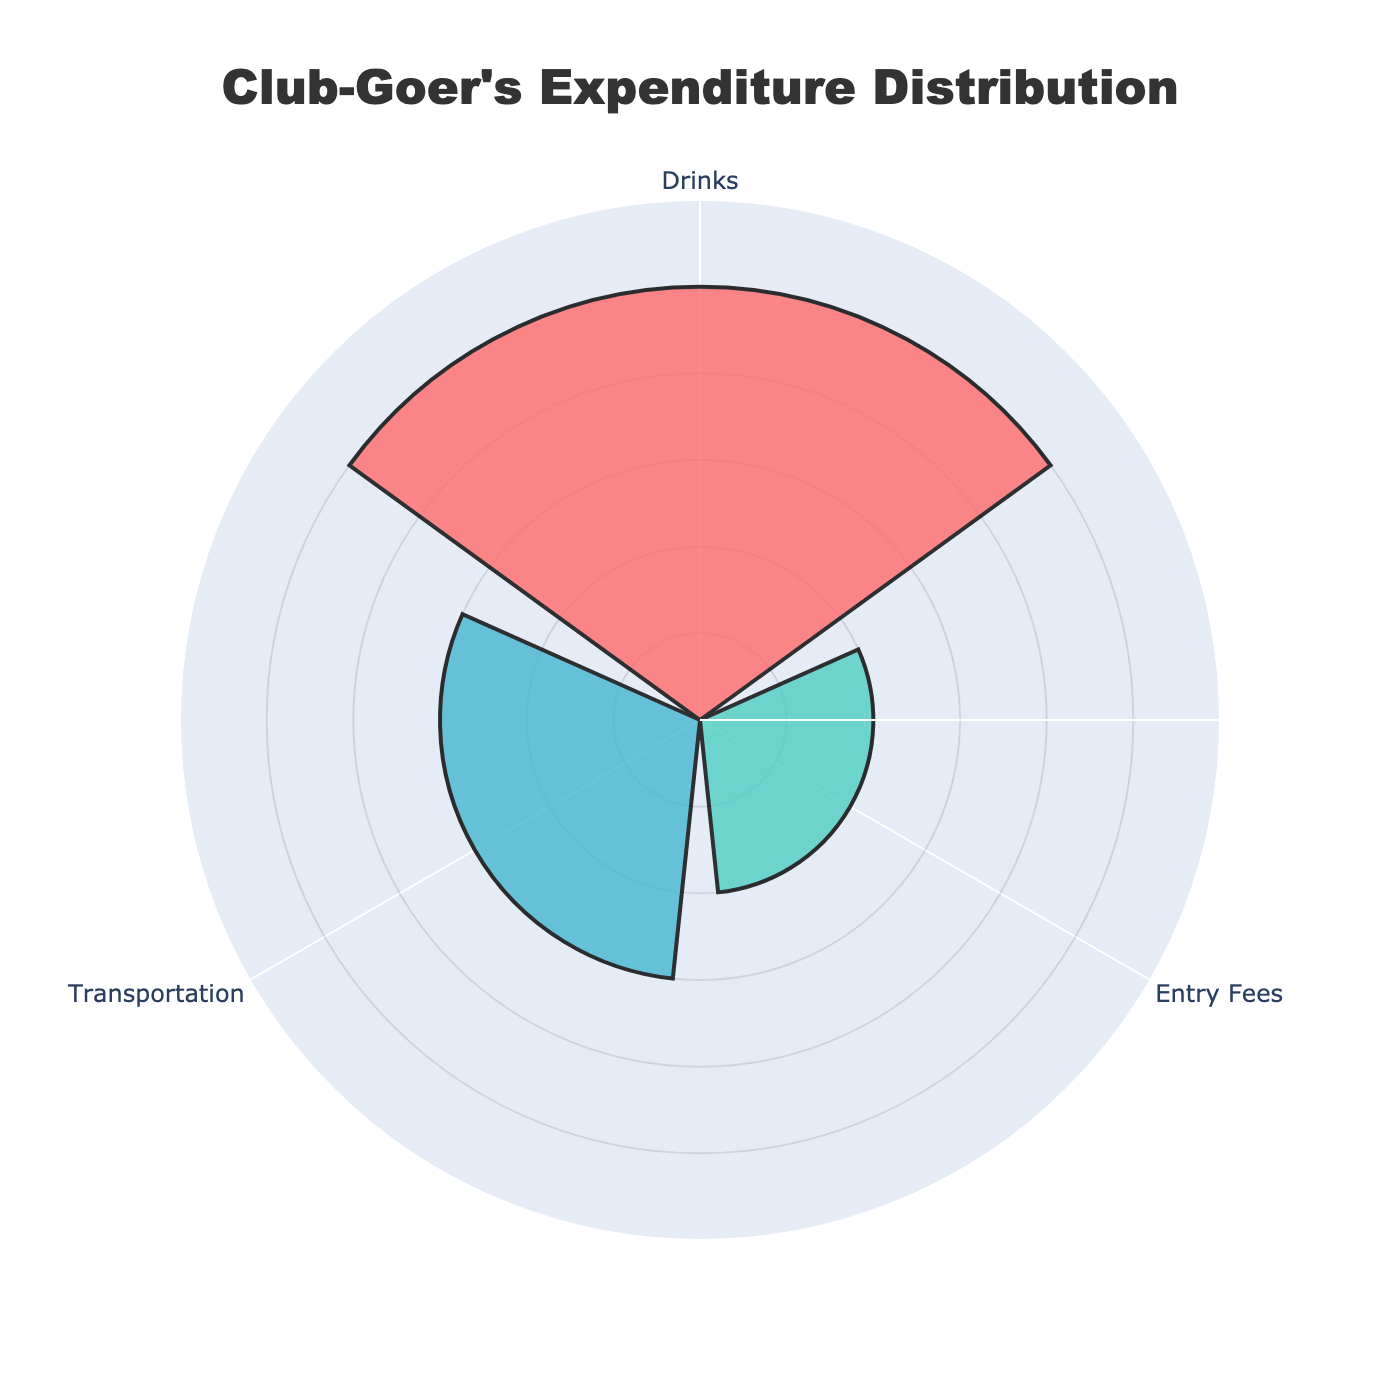How much is spent on drinks? According to the figure, the expenditure for drinks is represented visually. By observing the bar for drinks, we can see the value given.
Answer: $50 What is the total expenditure? To find the total expenditure, we sum up the expenditures in all categories. The values are $50 for drinks, $20 for entry fees, and $30 for transportation. Adding them together: $50 + $20 + $30
Answer: $100 Which category has the lowest expenditure? By comparing the lengths of the bars in the rose chart, it is evident which category has the smallest value. The bar for entry fees is the shortest.
Answer: Entry Fees How much more is spent on drinks compared to transportation? First, find the expenditure for drinks, which is $50. Then, find the expenditure for transportation, which is $30. Subtract the transportation value from the drinks value: $50 - $30
Answer: $20 What percentage of the total expenditure is spent on transportation? First, calculate the total expenditure: $50 (drinks) + $20 (entry fees) + $30 (transportation) = $100. Then, divide the transportation expenditure by the total: $30 / $100 = 0.3. Finally, convert it to a percentage by multiplying by 100: 0.3 * 100
Answer: 30% What is the average expenditure across all categories? To find the average, sum up the expenditures for drinks, entry fees, and transportation and then divide by the number of categories. Total expenditure: $50 + $20 + $30 = $100. Number of categories: 3. Average expenditure: $100 / 3
Answer: $33.33 Which category has the second-highest expenditure? By looking at the bar lengths, identify the highest expenditure first, which is for drinks ($50). Then, look for the second-highest, which is transportation ($30).
Answer: Transportation How much would one save by not spending on entry fees? The amount spent on entry fees is $20. If this expenditure is eliminated, the total expenditure will decrease by this amount.
Answer: $20 